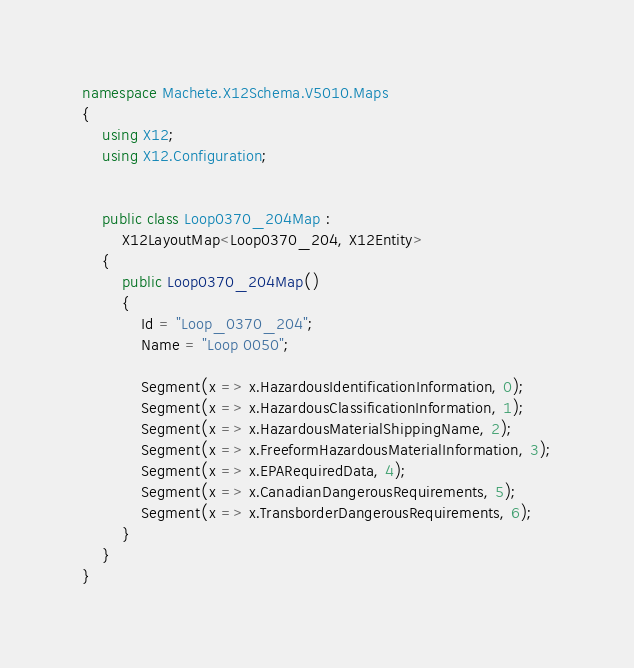<code> <loc_0><loc_0><loc_500><loc_500><_C#_>namespace Machete.X12Schema.V5010.Maps
{
    using X12;
    using X12.Configuration;


    public class Loop0370_204Map :
        X12LayoutMap<Loop0370_204, X12Entity>
    {
        public Loop0370_204Map()
        {
            Id = "Loop_0370_204";
            Name = "Loop 0050";
            
            Segment(x => x.HazardousIdentificationInformation, 0);
            Segment(x => x.HazardousClassificationInformation, 1);
            Segment(x => x.HazardousMaterialShippingName, 2);
            Segment(x => x.FreeformHazardousMaterialInformation, 3);
            Segment(x => x.EPARequiredData, 4);
            Segment(x => x.CanadianDangerousRequirements, 5);
            Segment(x => x.TransborderDangerousRequirements, 6);
        }
    }
}</code> 